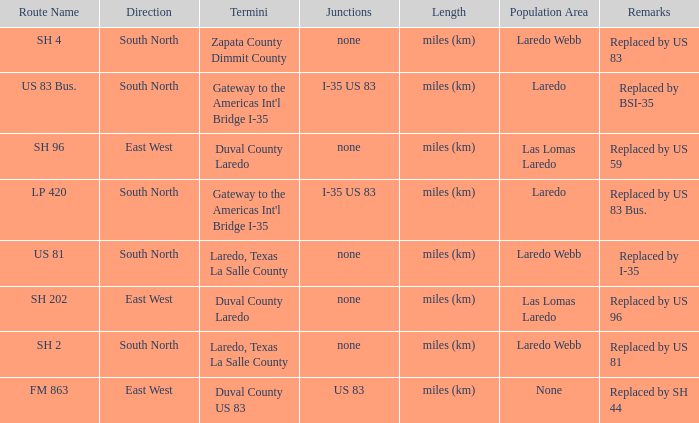What unit of length is being used for the route with "replaced by us 81" in their remarks section? Miles (km). 